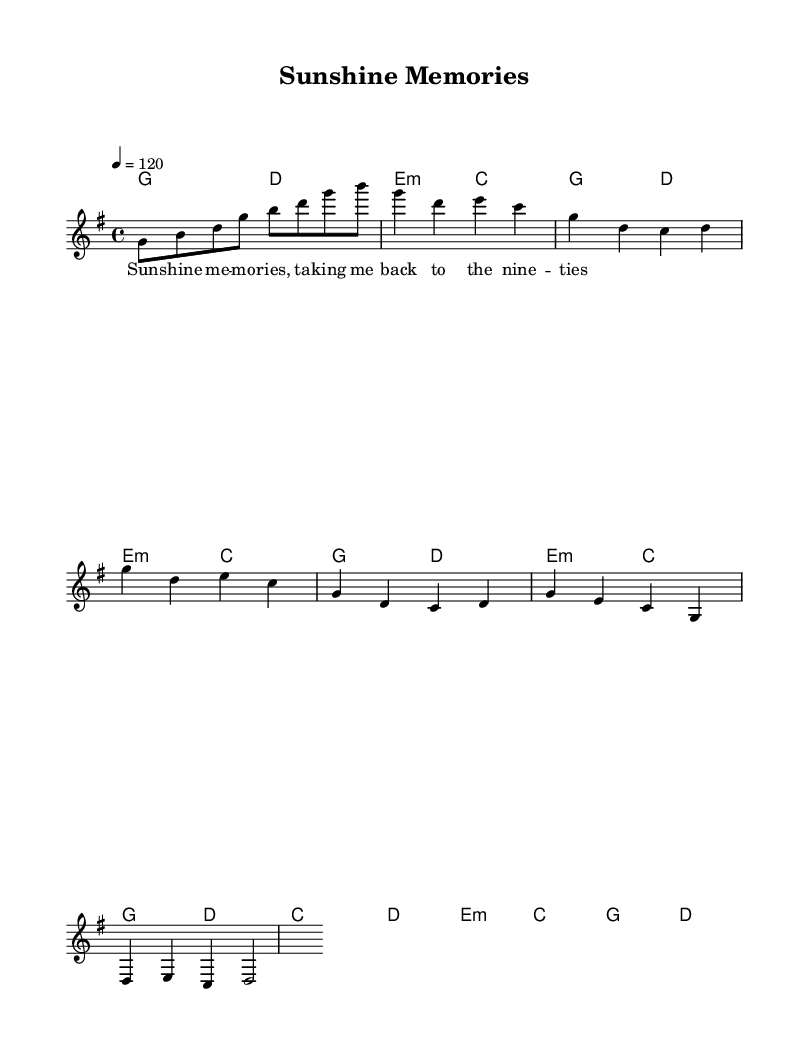What is the key signature of this music? The key signature is marked with one sharp (F#) shown as the beginning of the staff line which indicates that the piece is in G major.
Answer: G major What is the time signature of the music? The time signature is indicated as 4/4, which means there are four beats in a measure, and the quarter note gets one beat.
Answer: 4/4 What is the tempo marking for this piece? The tempo marking indicates that the piece is played at a speed of 120 beats per minute, which is referenced with "4 = 120".
Answer: 120 How many measures are present in the melody section? By counting the measures in the melody part, we find there are 10 distinct measures outlined in the music segment.
Answer: 10 Which chord comes after the chorus section? The harmony right after the chorus transitions into the E minor chord, noted in the chord progression.
Answer: E minor What is the main theme of the lyrics in the verse? The lyrics prominently mention "Sunshine Memories," which reflects the nostalgic theme of the piece centered around memories from the nineties.
Answer: Sunshine Memories What type of music is represented in this sheet? The sheet music is categorized as "Pop" because of its upbeat rhythm, catchy melodies, and common themes of nostalgia, typical for 90s pop music.
Answer: Pop 